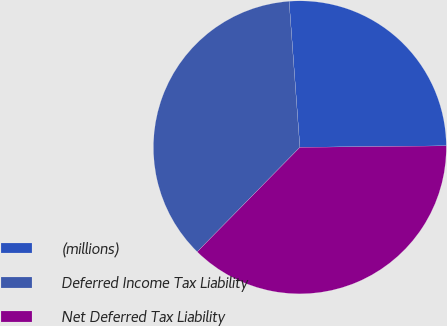<chart> <loc_0><loc_0><loc_500><loc_500><pie_chart><fcel>(millions)<fcel>Deferred Income Tax Liability<fcel>Net Deferred Tax Liability<nl><fcel>26.01%<fcel>36.47%<fcel>37.52%<nl></chart> 